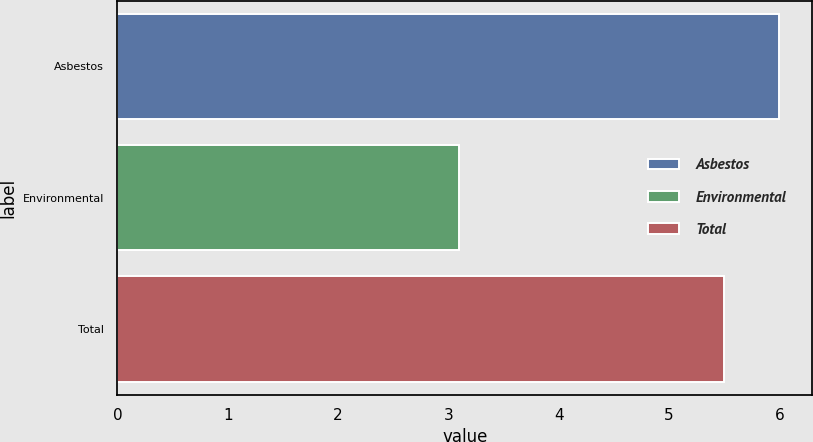Convert chart. <chart><loc_0><loc_0><loc_500><loc_500><bar_chart><fcel>Asbestos<fcel>Environmental<fcel>Total<nl><fcel>6<fcel>3.1<fcel>5.5<nl></chart> 